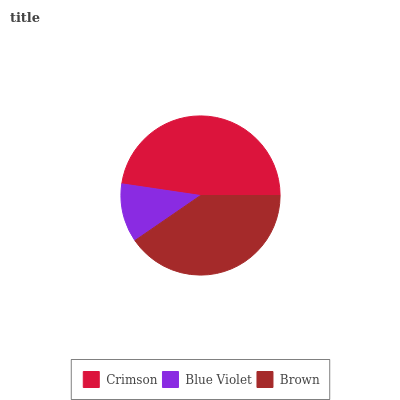Is Blue Violet the minimum?
Answer yes or no. Yes. Is Crimson the maximum?
Answer yes or no. Yes. Is Brown the minimum?
Answer yes or no. No. Is Brown the maximum?
Answer yes or no. No. Is Brown greater than Blue Violet?
Answer yes or no. Yes. Is Blue Violet less than Brown?
Answer yes or no. Yes. Is Blue Violet greater than Brown?
Answer yes or no. No. Is Brown less than Blue Violet?
Answer yes or no. No. Is Brown the high median?
Answer yes or no. Yes. Is Brown the low median?
Answer yes or no. Yes. Is Crimson the high median?
Answer yes or no. No. Is Crimson the low median?
Answer yes or no. No. 